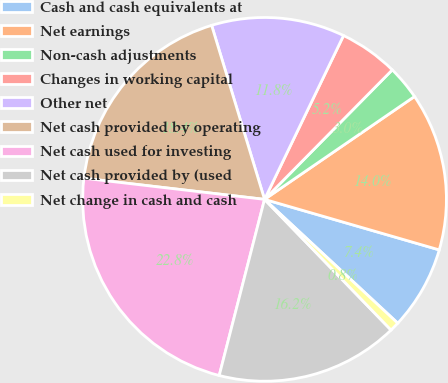Convert chart. <chart><loc_0><loc_0><loc_500><loc_500><pie_chart><fcel>Cash and cash equivalents at<fcel>Net earnings<fcel>Non-cash adjustments<fcel>Changes in working capital<fcel>Other net<fcel>Net cash provided by operating<fcel>Net cash used for investing<fcel>Net cash provided by (used<fcel>Net change in cash and cash<nl><fcel>7.44%<fcel>14.05%<fcel>3.04%<fcel>5.24%<fcel>11.85%<fcel>18.45%<fcel>22.85%<fcel>16.25%<fcel>0.84%<nl></chart> 